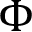<formula> <loc_0><loc_0><loc_500><loc_500>\Phi</formula> 